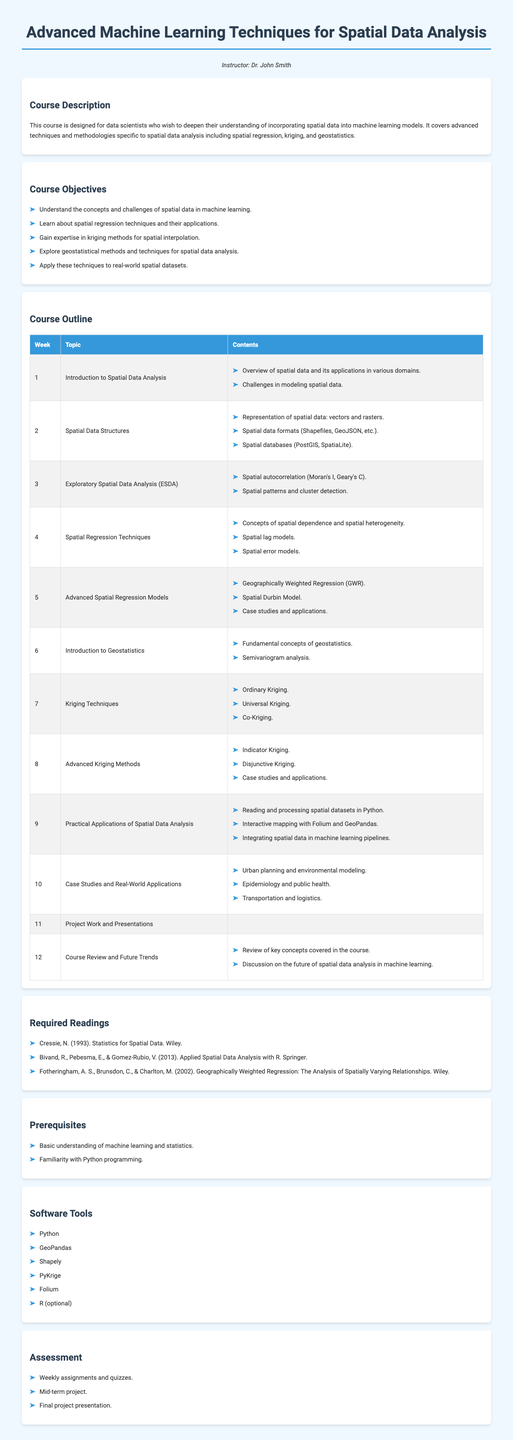What is the course title? The course title is found in the heading of the document, which is "Advanced Machine Learning Techniques for Spatial Data Analysis".
Answer: Advanced Machine Learning Techniques for Spatial Data Analysis Who is the instructor? The instructor's name is mentioned right after the course title in a separate paragraph.
Answer: Dr. John Smith How many weeks does the course last? The course outline indicates that the course consists of 12 weeks of content.
Answer: 12 What is the focus of week 4's topic? Week 4 covers "Spatial Regression Techniques", which includes concepts related to spatial dependence and spatial heterogeneity.
Answer: Spatial Regression Techniques Which software tools are required for the course? A list of software tools is provided; among them, Python is specifically listed as a requirement.
Answer: Python What type of readings are required for the course? The syllabus section on required readings provides names of books, which include works from different authors.
Answer: Books What is one of the practical applications mentioned for spatial data analysis in week 9? Week 9 discusses the application of reading and processing spatial datasets in Python.
Answer: Reading and processing spatial datasets in Python What is the course objective related to kriging methods? One of the objectives specifically states gaining expertise in kriging methods for spatial interpolation.
Answer: Expertise in kriging methods What kind of project is included in the assessment? The assessment section mentions a mid-term project as part of the evaluation criteria.
Answer: Mid-term project 